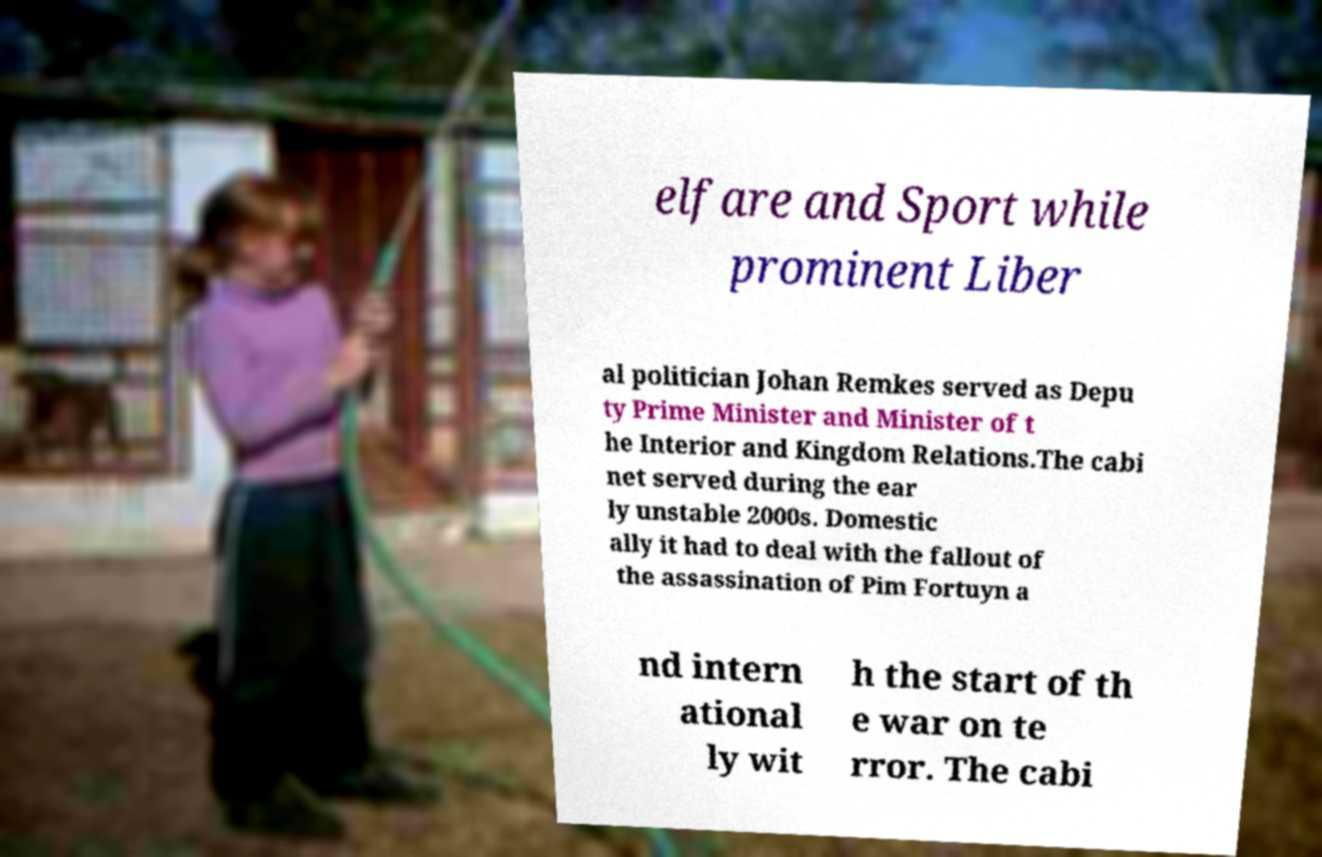Could you assist in decoding the text presented in this image and type it out clearly? elfare and Sport while prominent Liber al politician Johan Remkes served as Depu ty Prime Minister and Minister of t he Interior and Kingdom Relations.The cabi net served during the ear ly unstable 2000s. Domestic ally it had to deal with the fallout of the assassination of Pim Fortuyn a nd intern ational ly wit h the start of th e war on te rror. The cabi 